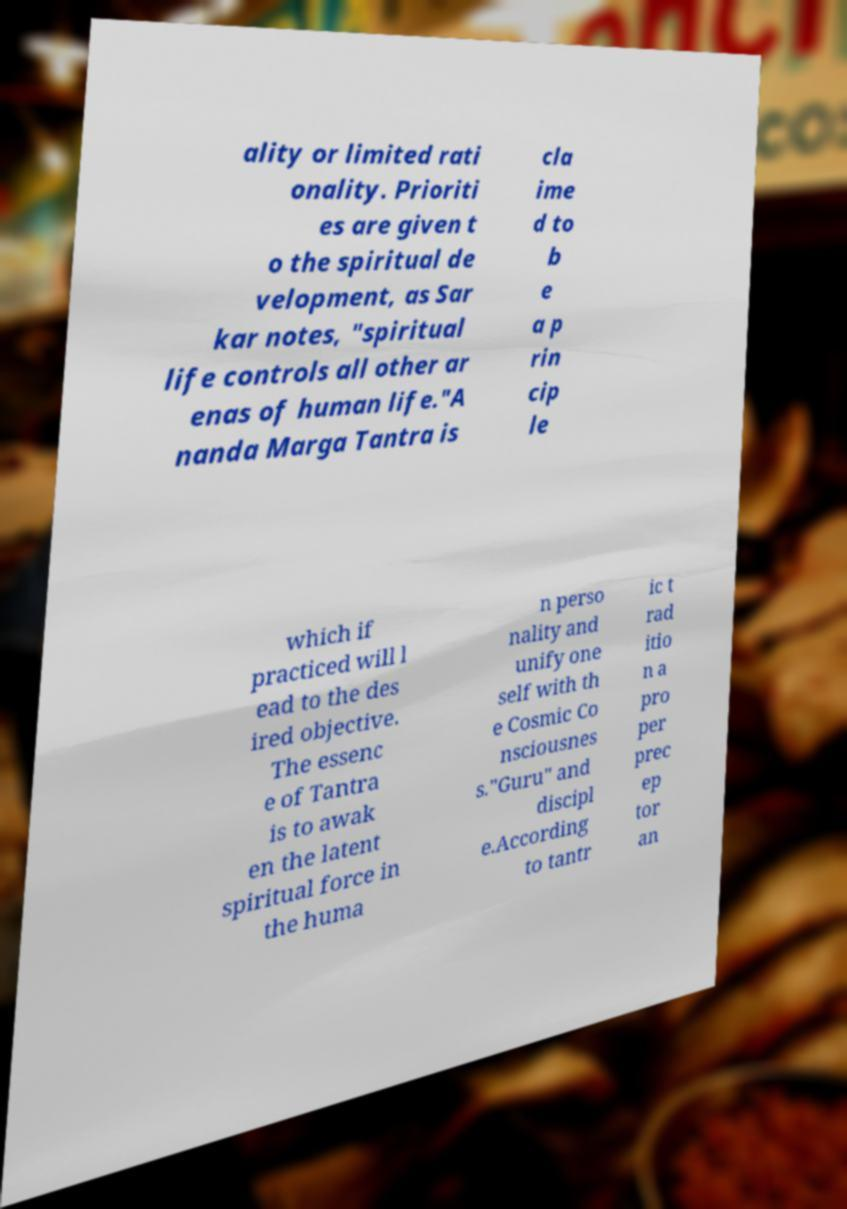Can you accurately transcribe the text from the provided image for me? ality or limited rati onality. Prioriti es are given t o the spiritual de velopment, as Sar kar notes, "spiritual life controls all other ar enas of human life."A nanda Marga Tantra is cla ime d to b e a p rin cip le which if practiced will l ead to the des ired objective. The essenc e of Tantra is to awak en the latent spiritual force in the huma n perso nality and unify one self with th e Cosmic Co nsciousnes s."Guru" and discipl e.According to tantr ic t rad itio n a pro per prec ep tor an 